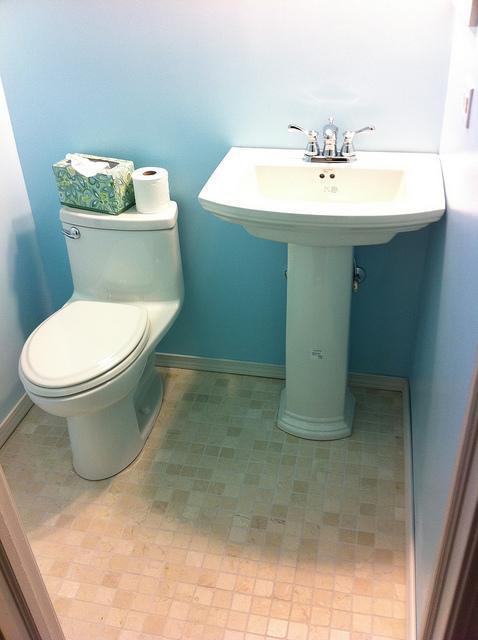How many sinks are there?
Give a very brief answer. 1. 